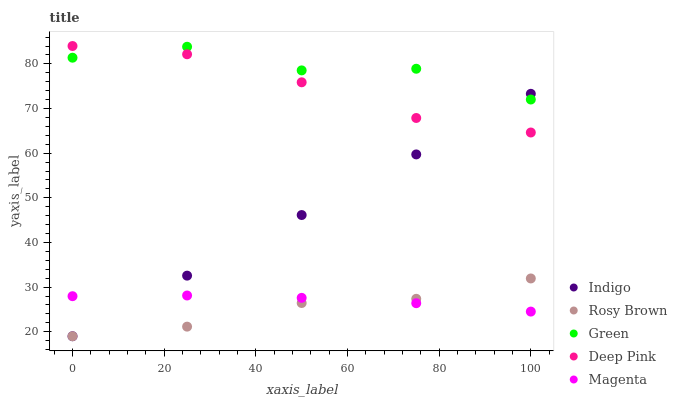Does Rosy Brown have the minimum area under the curve?
Answer yes or no. Yes. Does Green have the maximum area under the curve?
Answer yes or no. Yes. Does Magenta have the minimum area under the curve?
Answer yes or no. No. Does Magenta have the maximum area under the curve?
Answer yes or no. No. Is Indigo the smoothest?
Answer yes or no. Yes. Is Green the roughest?
Answer yes or no. Yes. Is Magenta the smoothest?
Answer yes or no. No. Is Magenta the roughest?
Answer yes or no. No. Does Rosy Brown have the lowest value?
Answer yes or no. Yes. Does Magenta have the lowest value?
Answer yes or no. No. Does Deep Pink have the highest value?
Answer yes or no. Yes. Does Rosy Brown have the highest value?
Answer yes or no. No. Is Magenta less than Green?
Answer yes or no. Yes. Is Deep Pink greater than Rosy Brown?
Answer yes or no. Yes. Does Rosy Brown intersect Indigo?
Answer yes or no. Yes. Is Rosy Brown less than Indigo?
Answer yes or no. No. Is Rosy Brown greater than Indigo?
Answer yes or no. No. Does Magenta intersect Green?
Answer yes or no. No. 